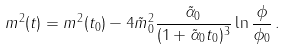<formula> <loc_0><loc_0><loc_500><loc_500>m ^ { 2 } ( t ) = m ^ { 2 } ( t _ { 0 } ) - 4 \tilde { m } _ { 0 } ^ { 2 } \frac { \tilde { \alpha } _ { 0 } } { ( 1 + \tilde { \alpha } _ { 0 } t _ { 0 } ) ^ { 3 } } \ln \frac { \phi } { \phi _ { 0 } } \, .</formula> 